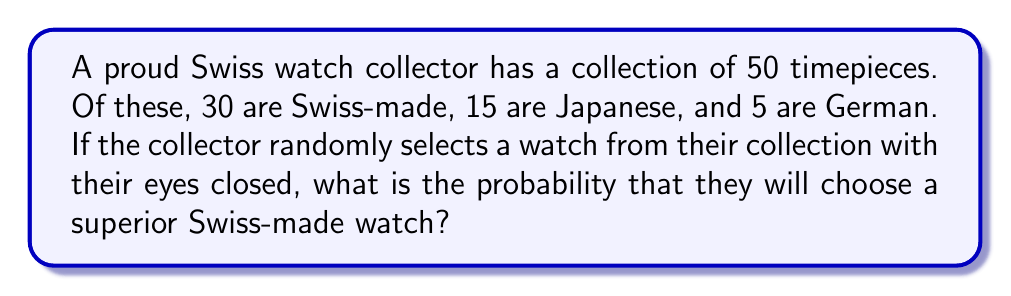Solve this math problem. To solve this problem, we need to use the concept of probability, which is the number of favorable outcomes divided by the total number of possible outcomes.

Let's break it down step by step:

1. Total number of watches in the collection:
   $$ \text{Total} = 30 + 15 + 5 = 50 $$

2. Number of Swiss-made watches:
   $$ \text{Swiss-made} = 30 $$

3. Probability of selecting a Swiss-made watch:
   $$ P(\text{Swiss-made}) = \frac{\text{Number of Swiss-made watches}}{\text{Total number of watches}} $$
   
   $$ P(\text{Swiss-made}) = \frac{30}{50} $$

4. Simplify the fraction:
   $$ P(\text{Swiss-made}) = \frac{3}{5} = 0.6 $$

Therefore, the probability of selecting a Swiss-made watch from the collection is $\frac{3}{5}$ or 0.6 or 60%.
Answer: $\frac{3}{5}$ or 0.6 or 60% 